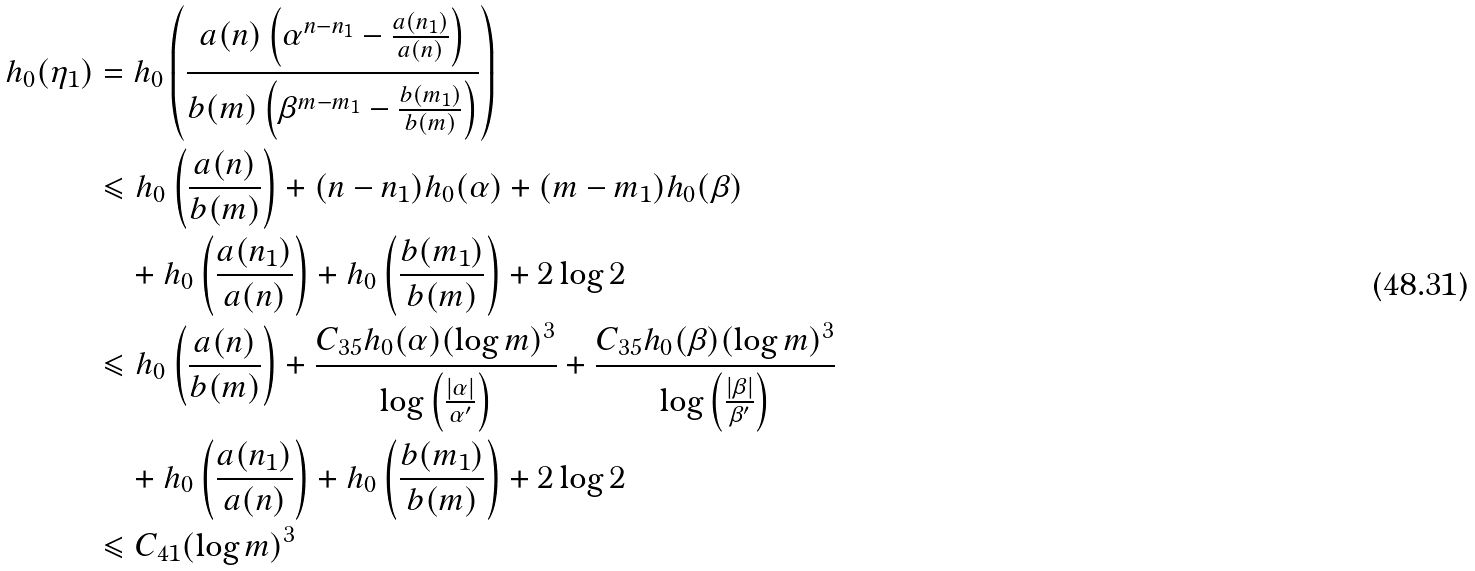Convert formula to latex. <formula><loc_0><loc_0><loc_500><loc_500>h _ { 0 } ( \eta _ { 1 } ) & = h _ { 0 } \left ( \frac { a ( n ) \left ( \alpha ^ { n - n _ { 1 } } - \frac { a ( n _ { 1 } ) } { a ( n ) } \right ) } { b ( m ) \left ( \beta ^ { m - m _ { 1 } } - \frac { b ( m _ { 1 } ) } { b ( m ) } \right ) } \right ) \\ & \leqslant h _ { 0 } \left ( \frac { a ( n ) } { b ( m ) } \right ) + ( n - n _ { 1 } ) h _ { 0 } ( \alpha ) + ( m - m _ { 1 } ) h _ { 0 } ( \beta ) \\ & \quad + h _ { 0 } \left ( \frac { a ( n _ { 1 } ) } { a ( n ) } \right ) + h _ { 0 } \left ( \frac { b ( m _ { 1 } ) } { b ( m ) } \right ) + 2 \log 2 \\ & \leqslant h _ { 0 } \left ( \frac { a ( n ) } { b ( m ) } \right ) + \frac { C _ { 3 5 } h _ { 0 } ( \alpha ) ( \log m ) ^ { 3 } } { \log \left ( \frac { | \alpha | } { \alpha ^ { \prime } } \right ) } + \frac { C _ { 3 5 } h _ { 0 } ( \beta ) ( \log m ) ^ { 3 } } { \log \left ( \frac { | \beta | } { \beta ^ { \prime } } \right ) } \\ & \quad + h _ { 0 } \left ( \frac { a ( n _ { 1 } ) } { a ( n ) } \right ) + h _ { 0 } \left ( \frac { b ( m _ { 1 } ) } { b ( m ) } \right ) + 2 \log 2 \\ & \leqslant C _ { 4 1 } ( \log m ) ^ { 3 }</formula> 